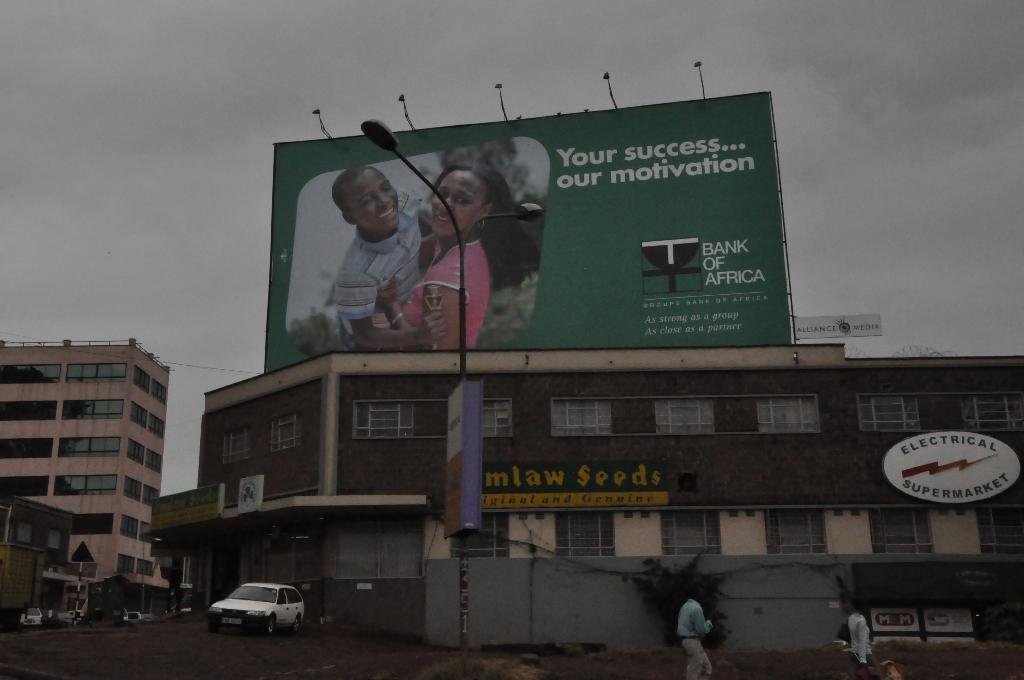<image>
Give a short and clear explanation of the subsequent image. a billboard that says 'your success... our motivation' on it 